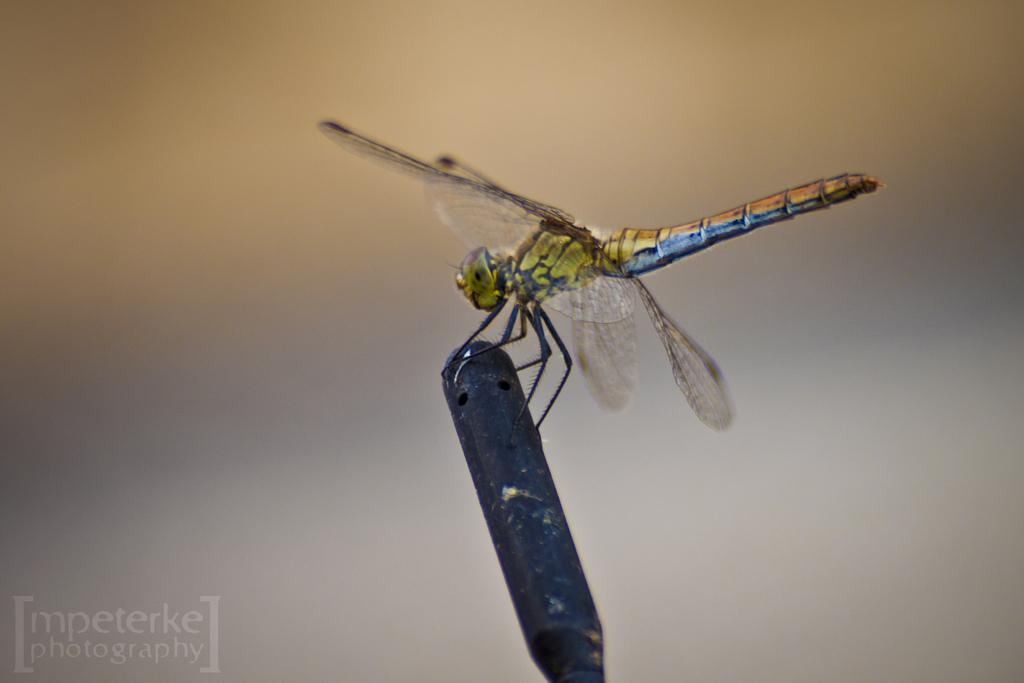What is the main subject in the center of the image? There is an insect in the center of the image. What can be found at the bottom of the image? There is an object at the bottom of the image. Are there any words or letters in the image? Yes, there is some text in the image. Where is the shade located in the image? There is no shade present in the image. What type of self-reflection can be seen in the image? There is no self-reflection present in the image. 